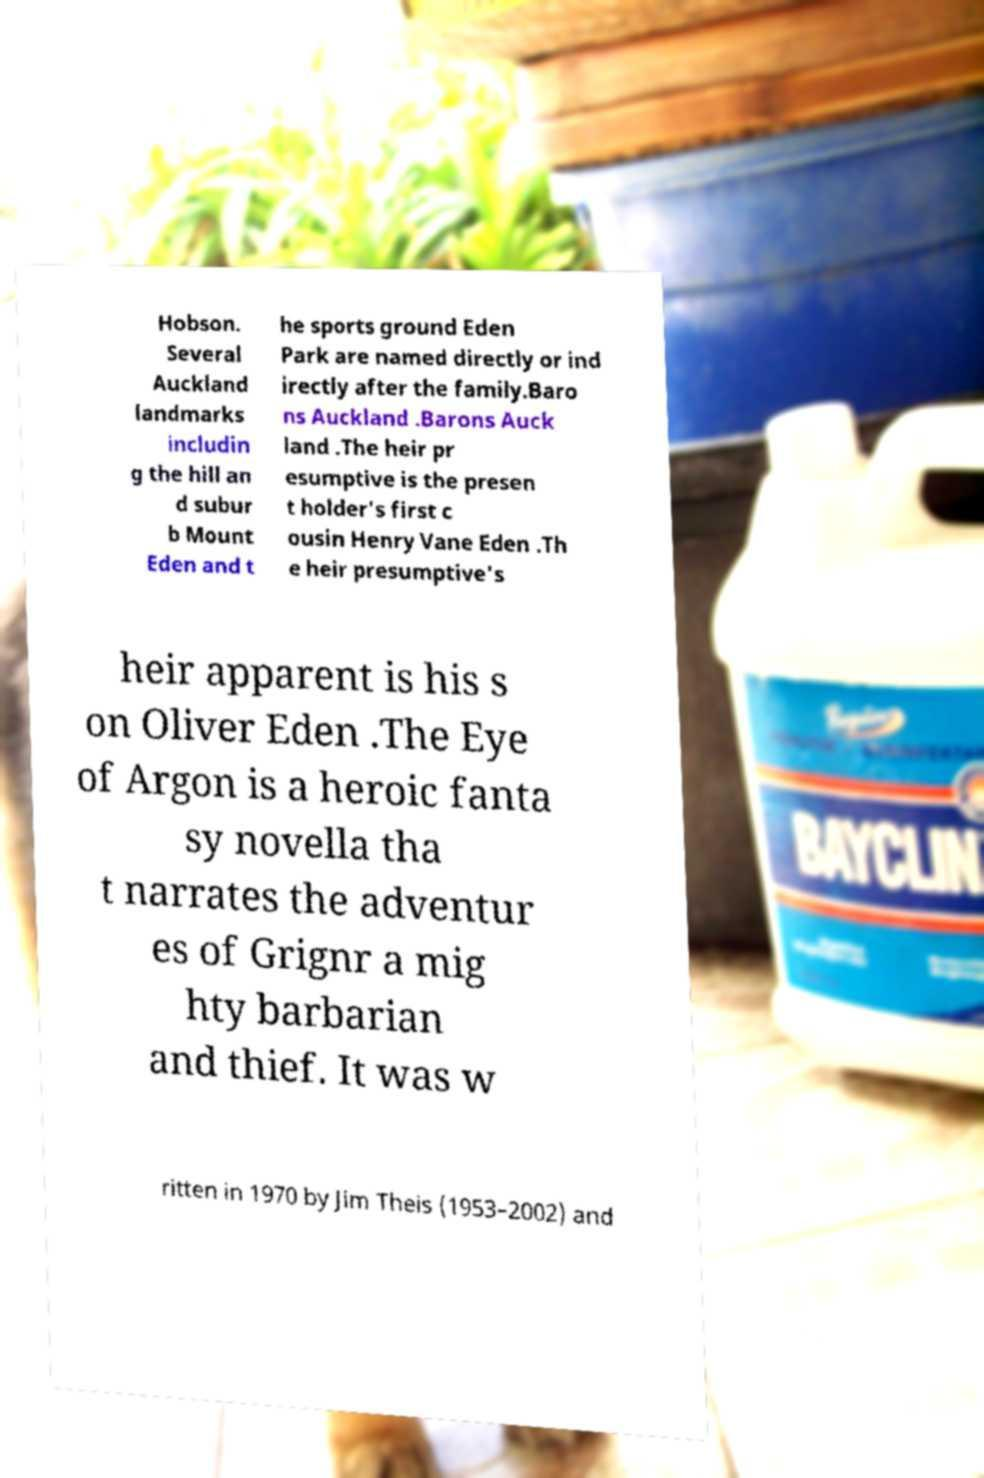Can you accurately transcribe the text from the provided image for me? Hobson. Several Auckland landmarks includin g the hill an d subur b Mount Eden and t he sports ground Eden Park are named directly or ind irectly after the family.Baro ns Auckland .Barons Auck land .The heir pr esumptive is the presen t holder's first c ousin Henry Vane Eden .Th e heir presumptive's heir apparent is his s on Oliver Eden .The Eye of Argon is a heroic fanta sy novella tha t narrates the adventur es of Grignr a mig hty barbarian and thief. It was w ritten in 1970 by Jim Theis (1953–2002) and 